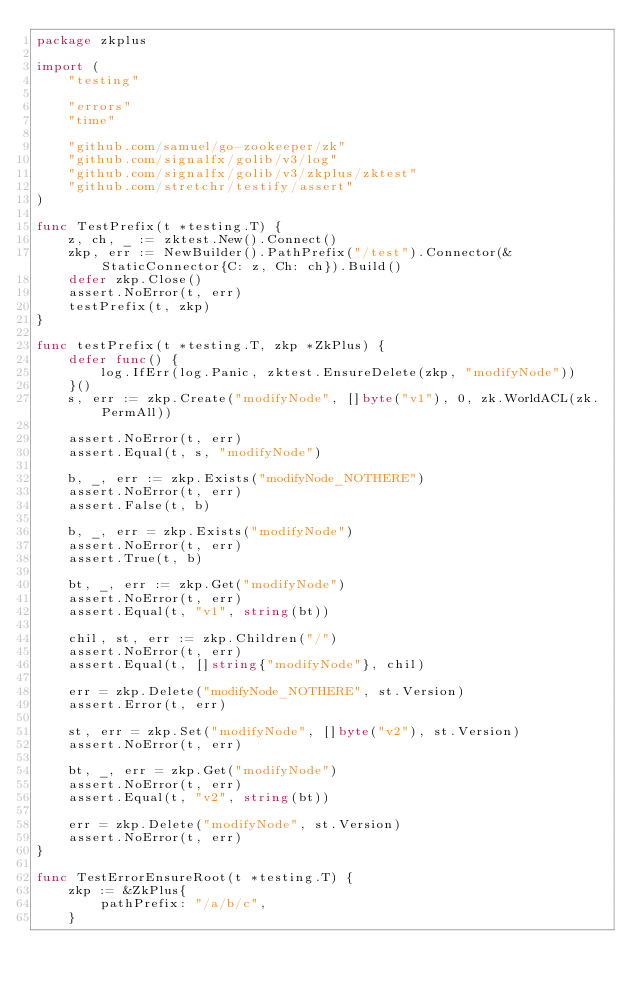<code> <loc_0><loc_0><loc_500><loc_500><_Go_>package zkplus

import (
	"testing"

	"errors"
	"time"

	"github.com/samuel/go-zookeeper/zk"
	"github.com/signalfx/golib/v3/log"
	"github.com/signalfx/golib/v3/zkplus/zktest"
	"github.com/stretchr/testify/assert"
)

func TestPrefix(t *testing.T) {
	z, ch, _ := zktest.New().Connect()
	zkp, err := NewBuilder().PathPrefix("/test").Connector(&StaticConnector{C: z, Ch: ch}).Build()
	defer zkp.Close()
	assert.NoError(t, err)
	testPrefix(t, zkp)
}

func testPrefix(t *testing.T, zkp *ZkPlus) {
	defer func() {
		log.IfErr(log.Panic, zktest.EnsureDelete(zkp, "modifyNode"))
	}()
	s, err := zkp.Create("modifyNode", []byte("v1"), 0, zk.WorldACL(zk.PermAll))

	assert.NoError(t, err)
	assert.Equal(t, s, "modifyNode")

	b, _, err := zkp.Exists("modifyNode_NOTHERE")
	assert.NoError(t, err)
	assert.False(t, b)

	b, _, err = zkp.Exists("modifyNode")
	assert.NoError(t, err)
	assert.True(t, b)

	bt, _, err := zkp.Get("modifyNode")
	assert.NoError(t, err)
	assert.Equal(t, "v1", string(bt))

	chil, st, err := zkp.Children("/")
	assert.NoError(t, err)
	assert.Equal(t, []string{"modifyNode"}, chil)

	err = zkp.Delete("modifyNode_NOTHERE", st.Version)
	assert.Error(t, err)

	st, err = zkp.Set("modifyNode", []byte("v2"), st.Version)
	assert.NoError(t, err)

	bt, _, err = zkp.Get("modifyNode")
	assert.NoError(t, err)
	assert.Equal(t, "v2", string(bt))

	err = zkp.Delete("modifyNode", st.Version)
	assert.NoError(t, err)
}

func TestErrorEnsureRoot(t *testing.T) {
	zkp := &ZkPlus{
		pathPrefix: "/a/b/c",
	}</code> 